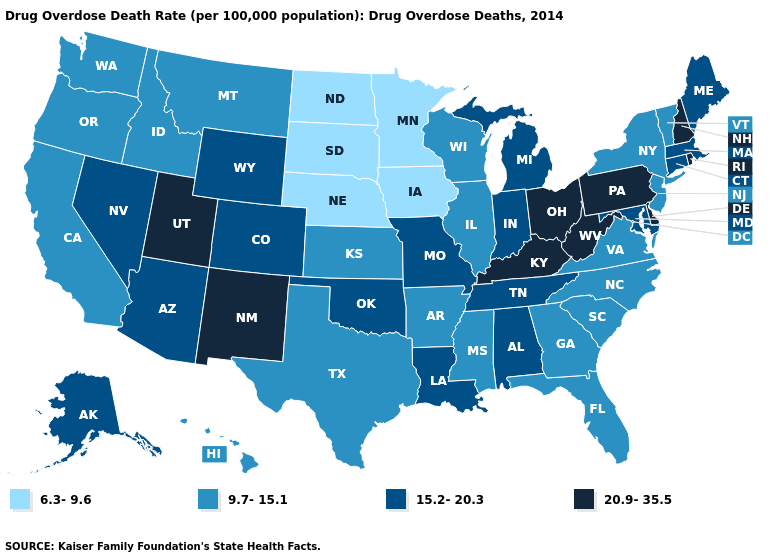Among the states that border Pennsylvania , which have the lowest value?
Be succinct. New Jersey, New York. Does Idaho have the lowest value in the West?
Answer briefly. Yes. What is the value of Pennsylvania?
Short answer required. 20.9-35.5. Which states have the lowest value in the USA?
Quick response, please. Iowa, Minnesota, Nebraska, North Dakota, South Dakota. What is the lowest value in states that border Wyoming?
Answer briefly. 6.3-9.6. Among the states that border Mississippi , which have the lowest value?
Give a very brief answer. Arkansas. Among the states that border Missouri , does Kentucky have the highest value?
Answer briefly. Yes. Which states hav the highest value in the West?
Keep it brief. New Mexico, Utah. Which states have the lowest value in the West?
Short answer required. California, Hawaii, Idaho, Montana, Oregon, Washington. Does New Mexico have a lower value than Oregon?
Keep it brief. No. What is the lowest value in states that border Nebraska?
Answer briefly. 6.3-9.6. Name the states that have a value in the range 20.9-35.5?
Keep it brief. Delaware, Kentucky, New Hampshire, New Mexico, Ohio, Pennsylvania, Rhode Island, Utah, West Virginia. Does the map have missing data?
Be succinct. No. Name the states that have a value in the range 20.9-35.5?
Keep it brief. Delaware, Kentucky, New Hampshire, New Mexico, Ohio, Pennsylvania, Rhode Island, Utah, West Virginia. What is the highest value in the Northeast ?
Keep it brief. 20.9-35.5. 